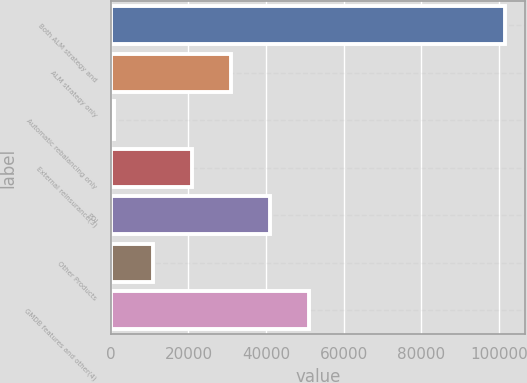Convert chart to OTSL. <chart><loc_0><loc_0><loc_500><loc_500><bar_chart><fcel>Both ALM strategy and<fcel>ALM strategy only<fcel>Automatic rebalancing only<fcel>External reinsurance(3)<fcel>PDI<fcel>Other Products<fcel>GMDB features and other(4)<nl><fcel>101496<fcel>31011.6<fcel>804<fcel>20942.4<fcel>41080.8<fcel>10873.2<fcel>51150<nl></chart> 